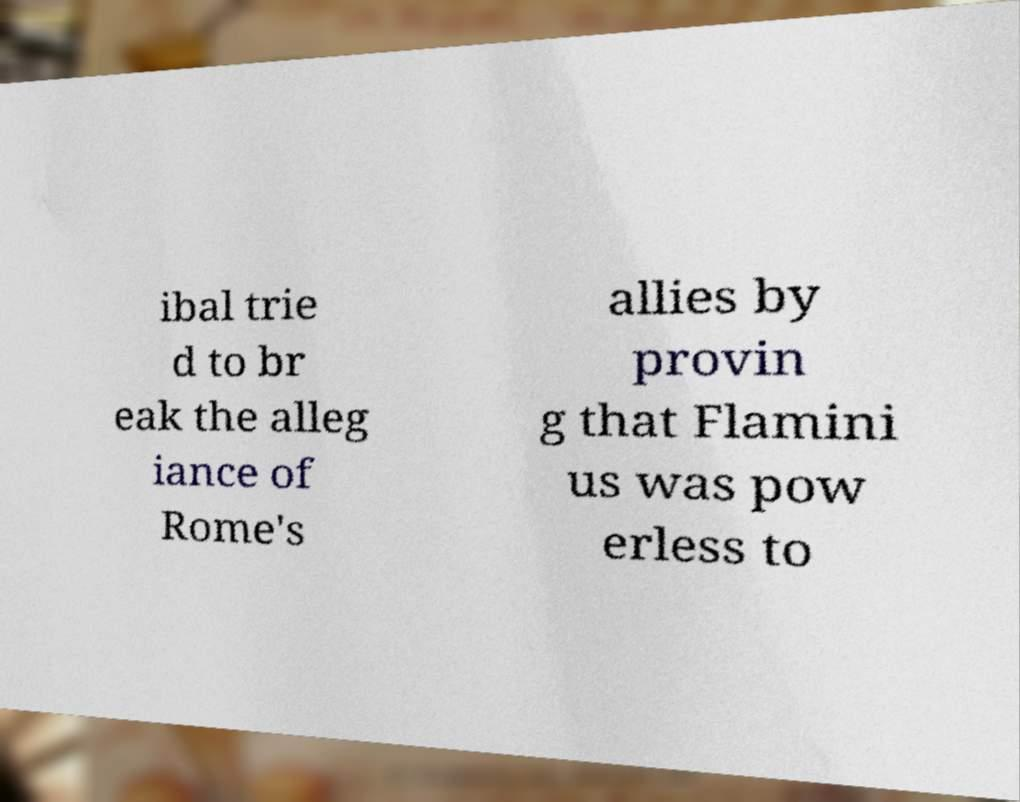I need the written content from this picture converted into text. Can you do that? ibal trie d to br eak the alleg iance of Rome's allies by provin g that Flamini us was pow erless to 